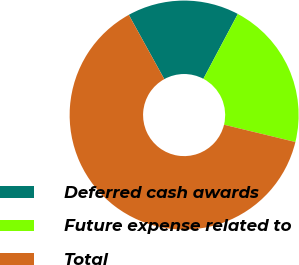<chart> <loc_0><loc_0><loc_500><loc_500><pie_chart><fcel>Deferred cash awards<fcel>Future expense related to<fcel>Total<nl><fcel>15.8%<fcel>21.01%<fcel>63.19%<nl></chart> 